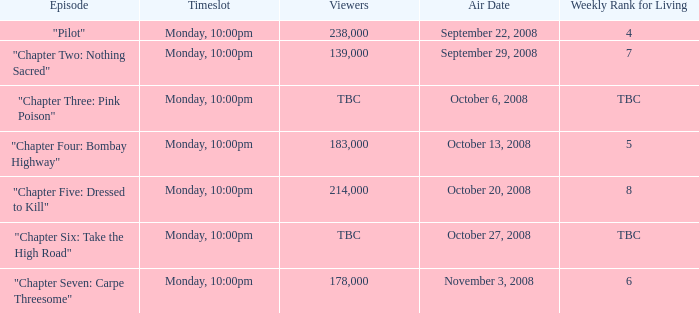How many viewers for the episode with the weekly rank for living of 4? 238000.0. 